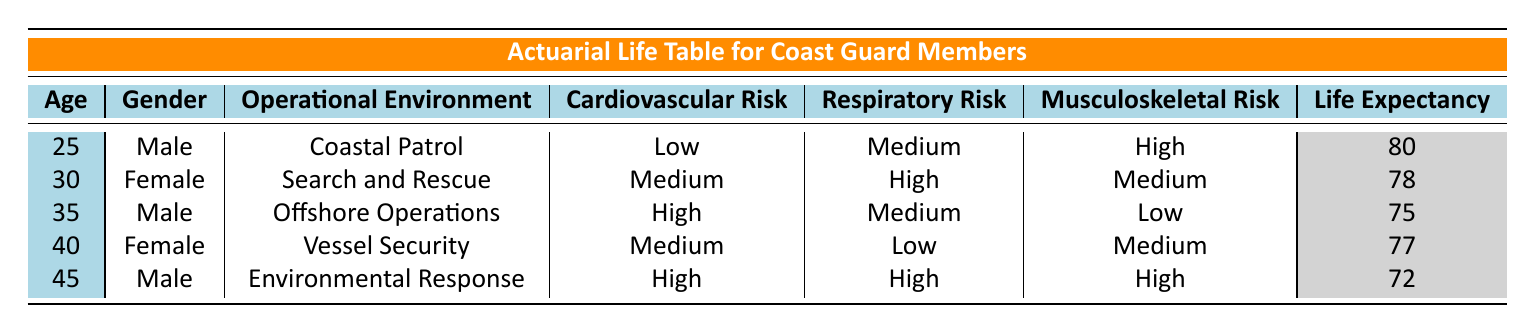What is the life expectancy of a 30-year-old female Coast Guard member? The table indicates the life expectancy directly associated with the 30-year-old female Coast Guard member, which is listed under the corresponding row. The life expectancy for this individual is 78 years.
Answer: 78 What operational environment has the highest reported musculoskeletal injury risk? By examining the health risks column for musculoskeletal injuries, we identify that the highest risk is categorized as "High" for the 25-year-old male in Coastal Patrol and the 45-year-old male in Environmental Response. Both environments show high risk, thus they share the highest category for musculoskeletal injuries.
Answer: Coastal Patrol and Environmental Response Is the cardiovascular disease risk for a non-smoking 40-year-old female high? Looking at the row for the 40-year-old female, we see her cardiovascular disease risk is listed as "Medium." Therefore, it is not high.
Answer: No What is the average life expectancy for male Coast Guard members in this table? The life expectancies for the male members in the table are 80 years, 75 years, and 72 years. Summing these gives (80 + 75 + 72) = 227. Since there are 3 males, the average life expectancy is calculated as 227 / 3 = 75.67, which rounds to 76 for reporting purposes.
Answer: 76 Which gender has a lower average life expectancy according to the table? The average life expectancy for females is (78 + 77) / 2 = 77.5, while for males it is (80 + 75 + 72) / 3 = 75.67. Since 75.67 is lower than 77.5, males have a lower average life expectancy compared to females.
Answer: Male Is there a Coast Guard member in the table with both high respiratory issues and musculoskeletal injuries? Examining the health risks for each member reveals that the 45-year-old male in Environmental Response has both high respiratory issues and high musculoskeletal injuries. Thus, the answer is yes.
Answer: Yes How many Coast Guard members are listed in high-risk categories for mental health issues? Looking through the mental health issues column, the 30-year-old female from Search and Rescue, the 40-year-old female from Vessel Security, and the 45-year-old male from Environmental Response are flagged as high risk. In total, there are 3 members rated as high risk for mental health issues.
Answer: 3 Is there a non-smoker in the table who works in Offshore Operations? The 35-year-old male in Offshore Operations is noted as a non-smoker in the table. Therefore, the answer is yes.
Answer: Yes 